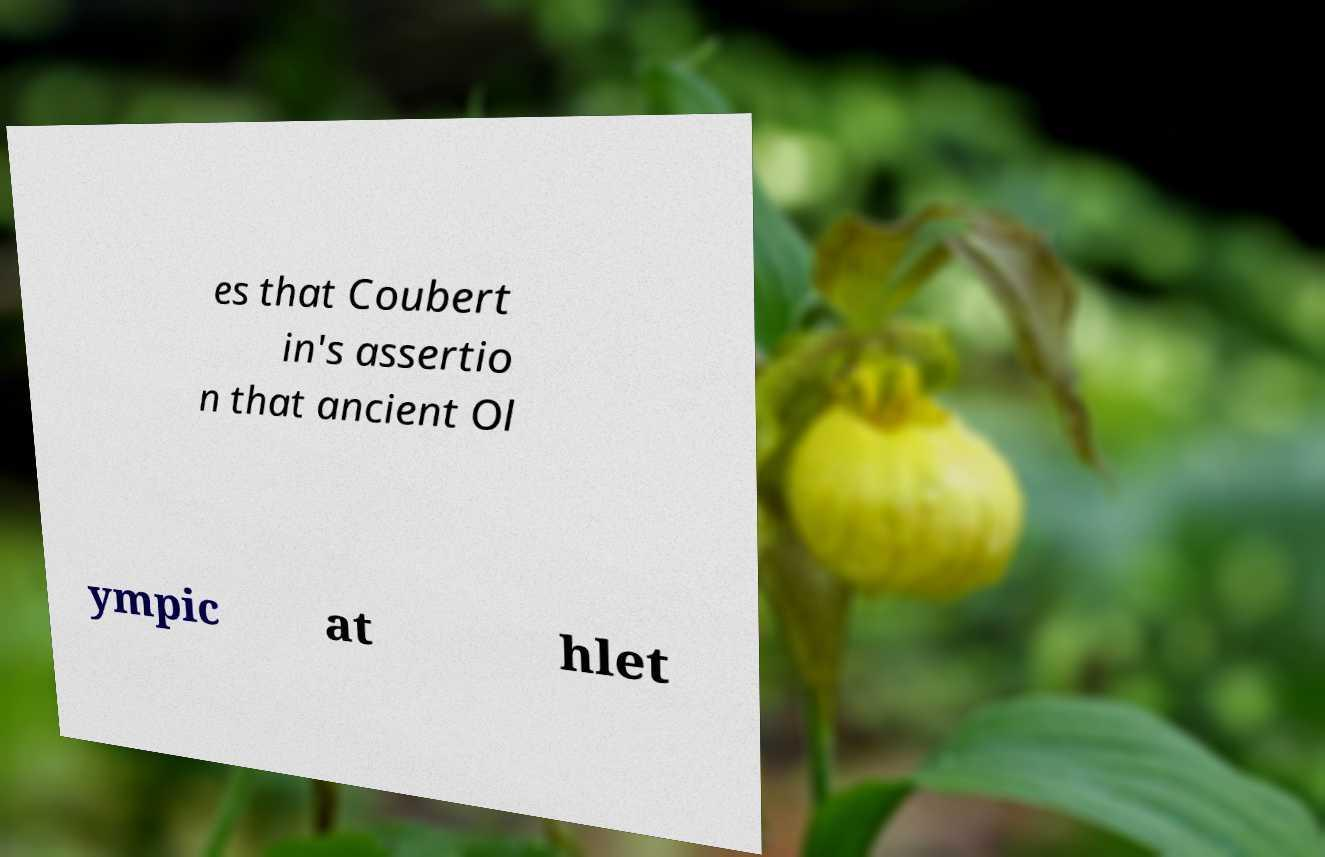Can you read and provide the text displayed in the image?This photo seems to have some interesting text. Can you extract and type it out for me? es that Coubert in's assertio n that ancient Ol ympic at hlet 